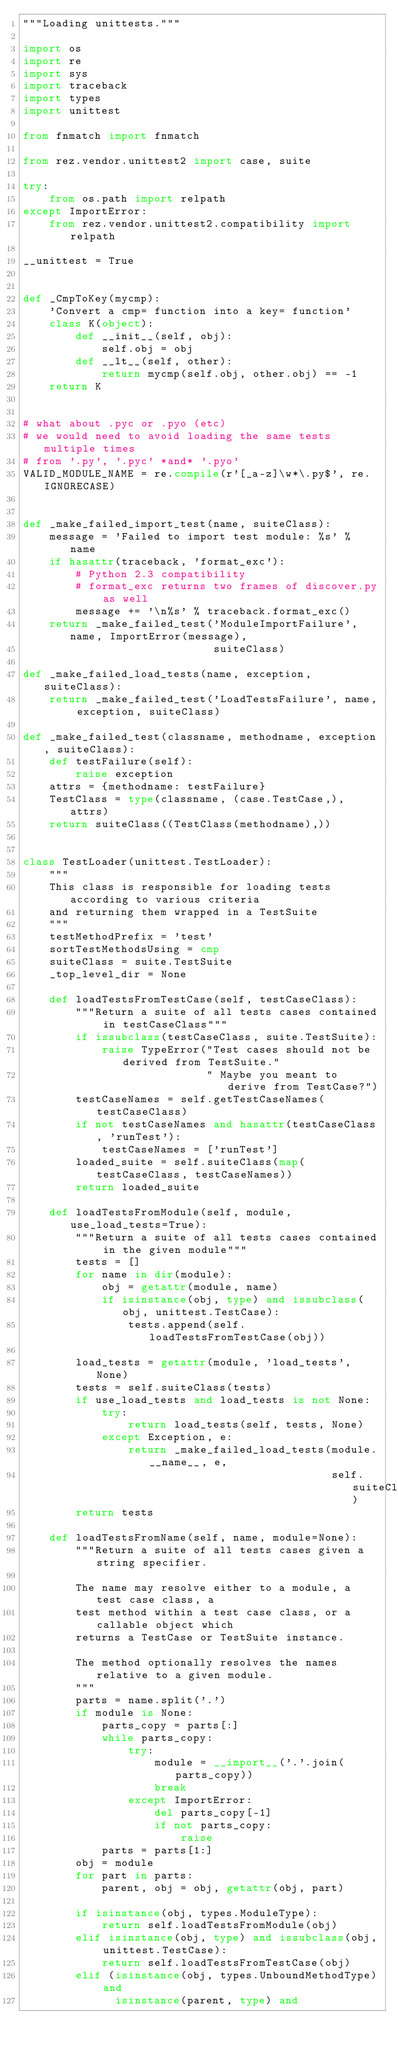Convert code to text. <code><loc_0><loc_0><loc_500><loc_500><_Python_>"""Loading unittests."""

import os
import re
import sys
import traceback
import types
import unittest

from fnmatch import fnmatch

from rez.vendor.unittest2 import case, suite

try:
    from os.path import relpath
except ImportError:
    from rez.vendor.unittest2.compatibility import relpath

__unittest = True


def _CmpToKey(mycmp):
    'Convert a cmp= function into a key= function'
    class K(object):
        def __init__(self, obj):
            self.obj = obj
        def __lt__(self, other):
            return mycmp(self.obj, other.obj) == -1
    return K


# what about .pyc or .pyo (etc)
# we would need to avoid loading the same tests multiple times
# from '.py', '.pyc' *and* '.pyo'
VALID_MODULE_NAME = re.compile(r'[_a-z]\w*\.py$', re.IGNORECASE)


def _make_failed_import_test(name, suiteClass):
    message = 'Failed to import test module: %s' % name
    if hasattr(traceback, 'format_exc'):
        # Python 2.3 compatibility
        # format_exc returns two frames of discover.py as well
        message += '\n%s' % traceback.format_exc()
    return _make_failed_test('ModuleImportFailure', name, ImportError(message),
                             suiteClass)

def _make_failed_load_tests(name, exception, suiteClass):
    return _make_failed_test('LoadTestsFailure', name, exception, suiteClass)

def _make_failed_test(classname, methodname, exception, suiteClass):
    def testFailure(self):
        raise exception
    attrs = {methodname: testFailure}
    TestClass = type(classname, (case.TestCase,), attrs)
    return suiteClass((TestClass(methodname),))
    

class TestLoader(unittest.TestLoader):
    """
    This class is responsible for loading tests according to various criteria
    and returning them wrapped in a TestSuite
    """
    testMethodPrefix = 'test'
    sortTestMethodsUsing = cmp
    suiteClass = suite.TestSuite
    _top_level_dir = None

    def loadTestsFromTestCase(self, testCaseClass):
        """Return a suite of all tests cases contained in testCaseClass"""
        if issubclass(testCaseClass, suite.TestSuite):
            raise TypeError("Test cases should not be derived from TestSuite."
                            " Maybe you meant to derive from TestCase?")
        testCaseNames = self.getTestCaseNames(testCaseClass)
        if not testCaseNames and hasattr(testCaseClass, 'runTest'):
            testCaseNames = ['runTest']
        loaded_suite = self.suiteClass(map(testCaseClass, testCaseNames))
        return loaded_suite

    def loadTestsFromModule(self, module, use_load_tests=True):
        """Return a suite of all tests cases contained in the given module"""
        tests = []
        for name in dir(module):
            obj = getattr(module, name)
            if isinstance(obj, type) and issubclass(obj, unittest.TestCase):
                tests.append(self.loadTestsFromTestCase(obj))

        load_tests = getattr(module, 'load_tests', None)
        tests = self.suiteClass(tests)
        if use_load_tests and load_tests is not None:
            try:
                return load_tests(self, tests, None)
            except Exception, e:
                return _make_failed_load_tests(module.__name__, e,
                                               self.suiteClass)
        return tests

    def loadTestsFromName(self, name, module=None):
        """Return a suite of all tests cases given a string specifier.

        The name may resolve either to a module, a test case class, a
        test method within a test case class, or a callable object which
        returns a TestCase or TestSuite instance.

        The method optionally resolves the names relative to a given module.
        """
        parts = name.split('.')
        if module is None:
            parts_copy = parts[:]
            while parts_copy:
                try:
                    module = __import__('.'.join(parts_copy))
                    break
                except ImportError:
                    del parts_copy[-1]
                    if not parts_copy:
                        raise
            parts = parts[1:]
        obj = module
        for part in parts:
            parent, obj = obj, getattr(obj, part)

        if isinstance(obj, types.ModuleType):
            return self.loadTestsFromModule(obj)
        elif isinstance(obj, type) and issubclass(obj, unittest.TestCase):
            return self.loadTestsFromTestCase(obj)
        elif (isinstance(obj, types.UnboundMethodType) and
              isinstance(parent, type) and</code> 